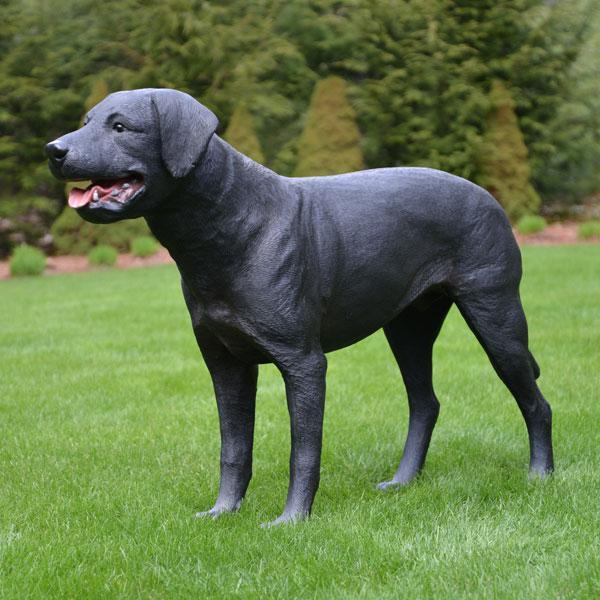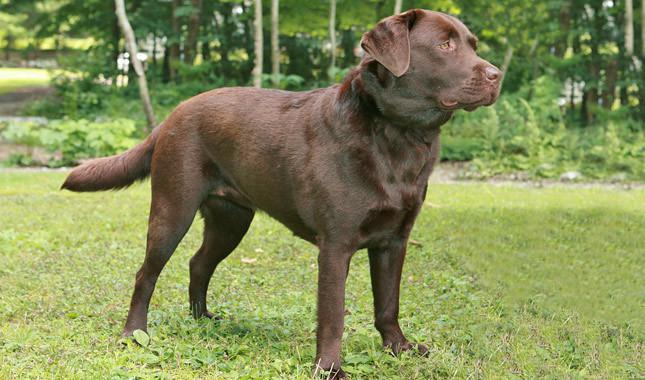The first image is the image on the left, the second image is the image on the right. For the images shown, is this caption "Only one of the dogs is black." true? Answer yes or no. Yes. 